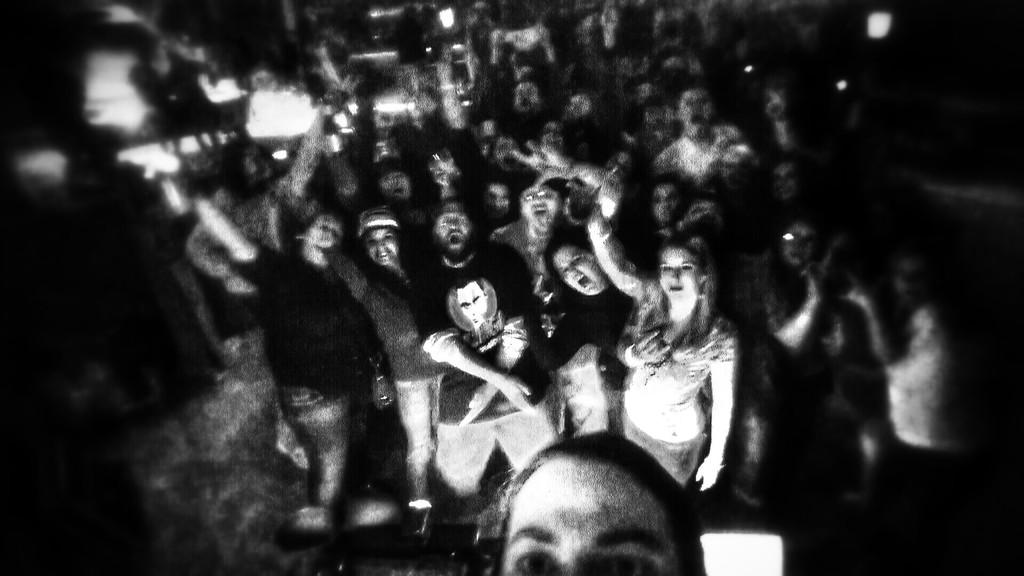Who or what can be seen in the image? There are people in the image. What else is present in the image besides the people? There are lights in the image. Can you see any icicles hanging from the people in the image? There are no icicles present in the image. What type of sheet is covering the people in the image? There are no sheets present in the image; the people are not covered. 